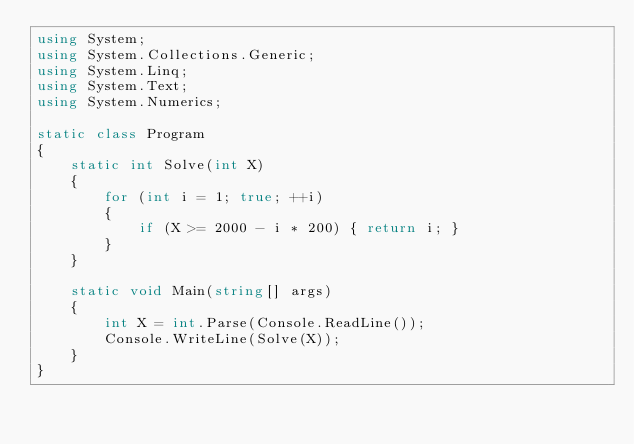<code> <loc_0><loc_0><loc_500><loc_500><_C#_>using System;
using System.Collections.Generic;
using System.Linq;
using System.Text;
using System.Numerics;

static class Program
{
    static int Solve(int X)
    {
        for (int i = 1; true; ++i)
        {
            if (X >= 2000 - i * 200) { return i; }
        }
    }

    static void Main(string[] args)
    {
        int X = int.Parse(Console.ReadLine());
        Console.WriteLine(Solve(X));
    }
}
</code> 